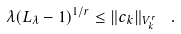<formula> <loc_0><loc_0><loc_500><loc_500>\lambda ( L _ { \lambda } - 1 ) ^ { 1 / r } \leq \| c _ { k } \| _ { V ^ { r } _ { k } } \ \ .</formula> 